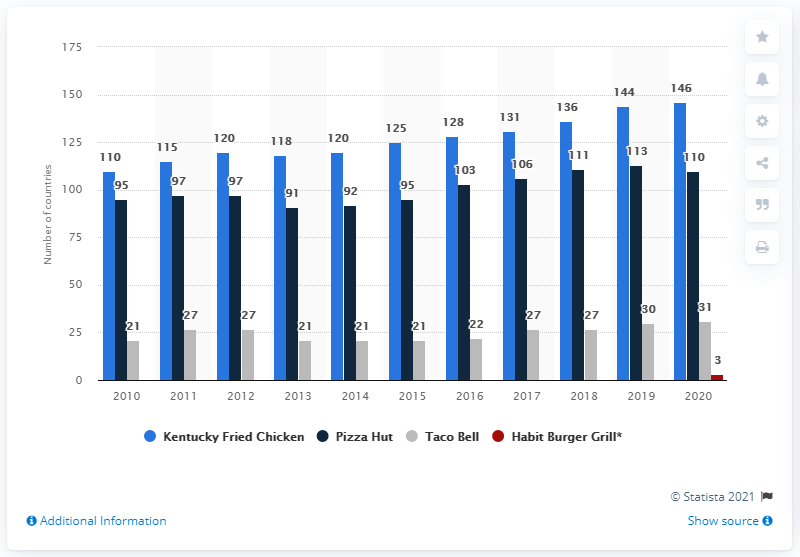Mention a couple of crucial points in this snapshot. It is my understanding that in 2020, Kentucky Fried Chicken was operating as a restaurant in 144 countries across the world. In the year 2010, the number of KFC restaurants worldwide increased significantly. Between 2010 and 2011, YUM! Brands operated in a record-breaking 115 countries worldwide, solidifying its position as a global restaurant powerhouse. In 2010, YUM! Brands operated in a record-breaking 110 countries, solidifying its position as a global force in the fast food industry. 